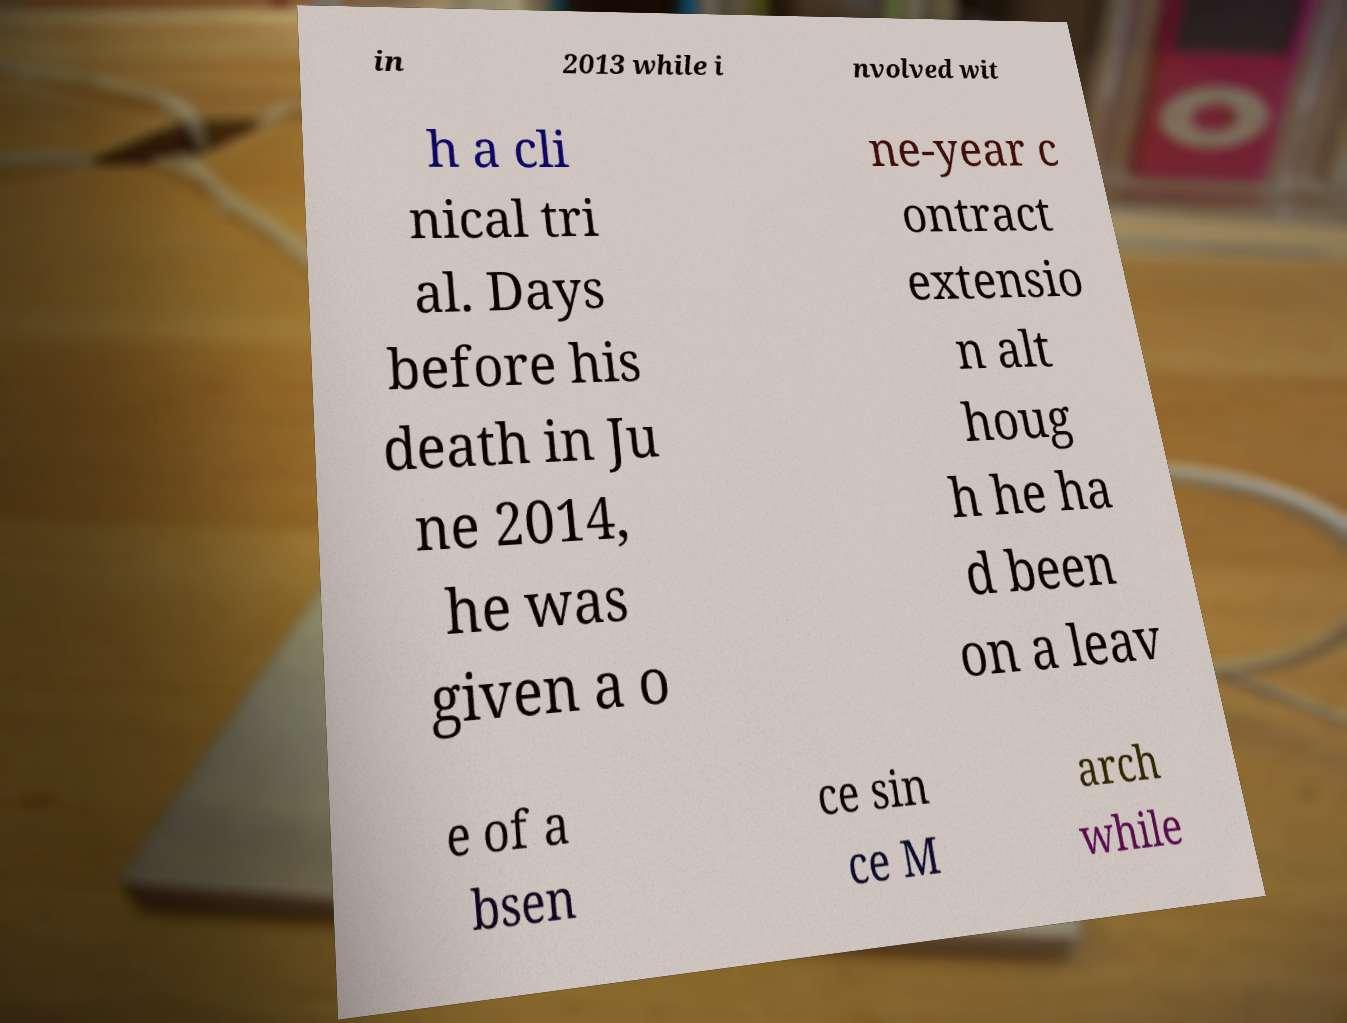Could you assist in decoding the text presented in this image and type it out clearly? in 2013 while i nvolved wit h a cli nical tri al. Days before his death in Ju ne 2014, he was given a o ne-year c ontract extensio n alt houg h he ha d been on a leav e of a bsen ce sin ce M arch while 